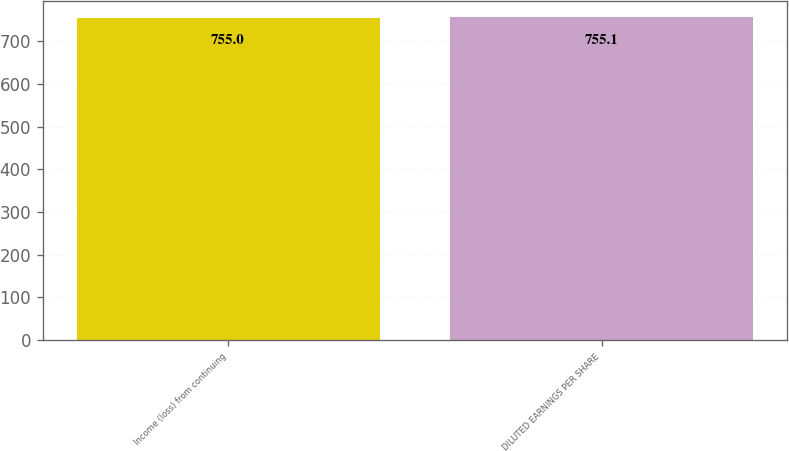Convert chart to OTSL. <chart><loc_0><loc_0><loc_500><loc_500><bar_chart><fcel>Income (loss) from continuing<fcel>DILUTED EARNINGS PER SHARE<nl><fcel>755<fcel>755.1<nl></chart> 